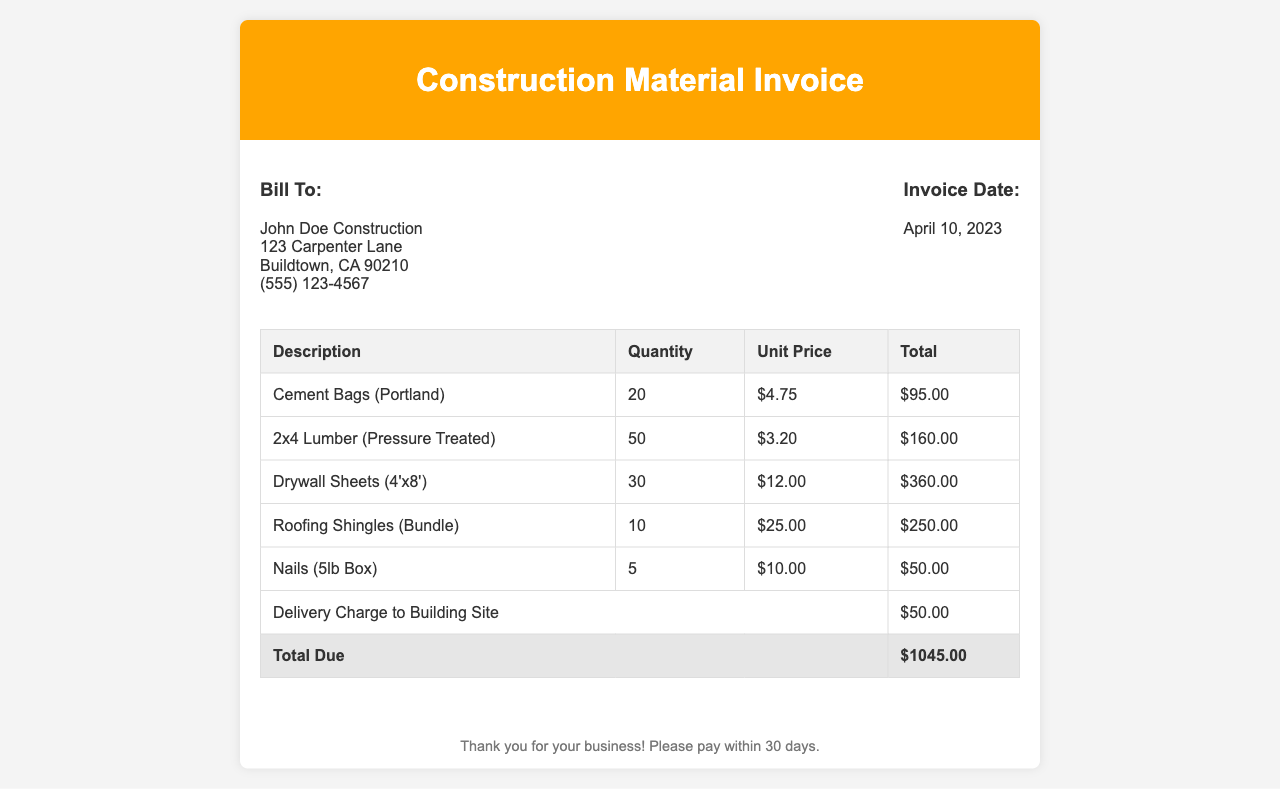What is the invoice date? The invoice date is given in the document as the date when the invoice was created.
Answer: April 10, 2023 Who is the bill to? The document specifies the individual or company receiving the invoice, which is detailed in the "Bill To" section.
Answer: John Doe Construction What is the total due? The total due is the sum of all line items and delivery charges, as indicated at the bottom of the invoice table.
Answer: $1045.00 How many drywall sheets were purchased? The quantity of drywall sheets is listed in the table under the relevant item description.
Answer: 30 What is the unit price of roofing shingles? The unit price is found in the table associated with the roofing shingles item.
Answer: $25.00 What is the delivery charge? The delivery charge is a specific line item included in the invoice, which details the cost of delivering materials.
Answer: $50.00 How many cement bags were ordered? The order quantity for cement bags is displayed in the table next to the description of the item.
Answer: 20 Which material had the highest cost? To determine this, we need to compare the total costs of each item listed. Based on the table, the material with the highest total cost is identified.
Answer: Drywall Sheets (4'x8') What is the quantity of nails purchased? The quantity of nails is indicated in the invoice table under the item for nails.
Answer: 5 